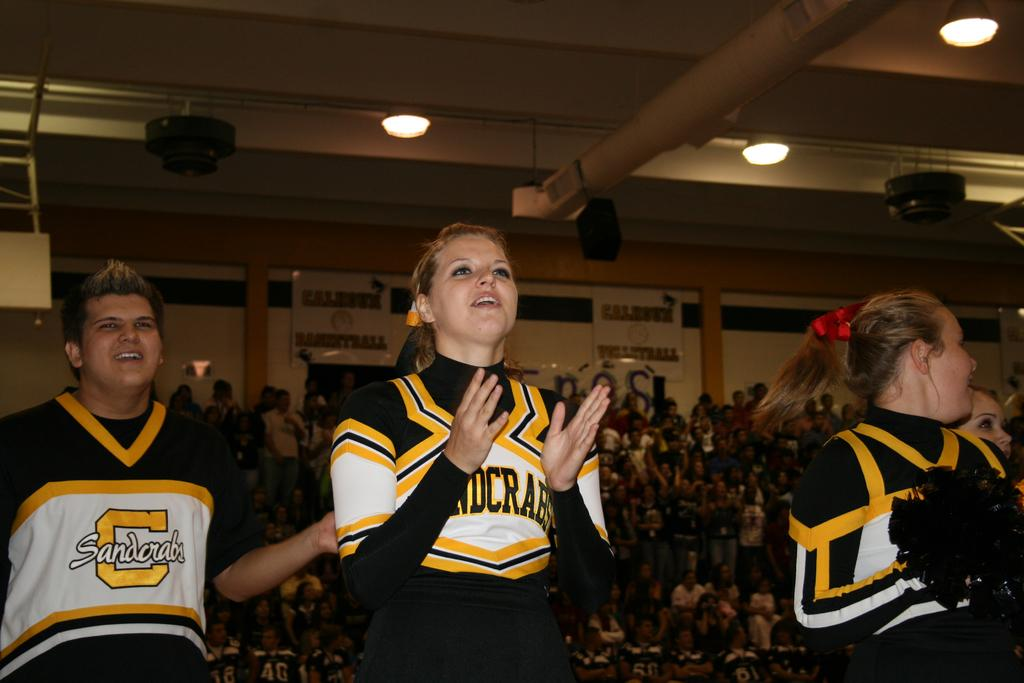<image>
Share a concise interpretation of the image provided. Members of the Sandcrabs cheer team get the fans fired up! 